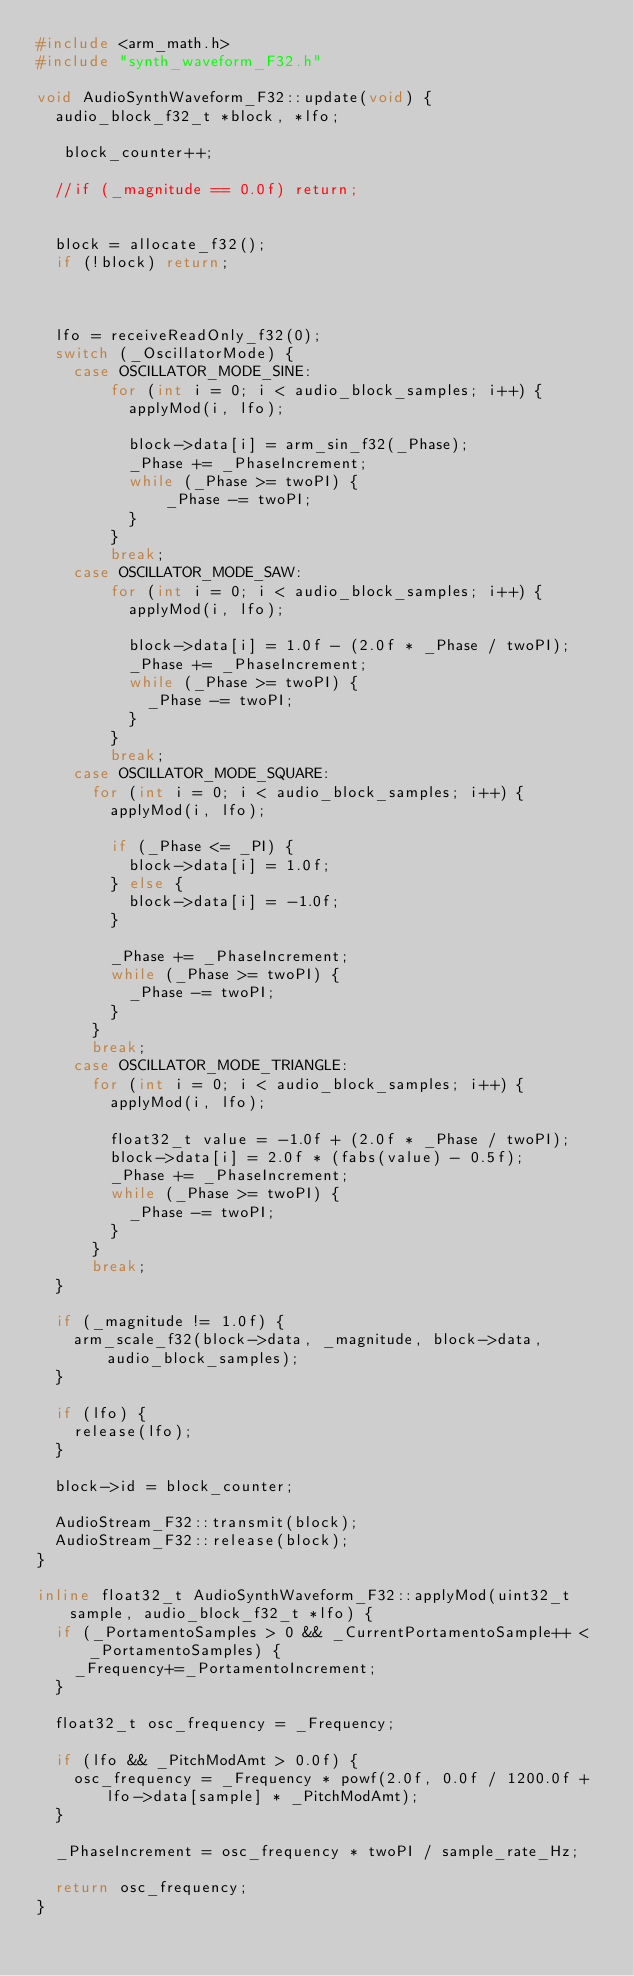<code> <loc_0><loc_0><loc_500><loc_500><_C++_>#include <arm_math.h>
#include "synth_waveform_F32.h"

void AudioSynthWaveform_F32::update(void) {
  audio_block_f32_t *block, *lfo;

   block_counter++;
	
  //if (_magnitude == 0.0f) return;
  

  block = allocate_f32();
  if (!block) return;
  
  

  lfo = receiveReadOnly_f32(0);
  switch (_OscillatorMode) {
    case OSCILLATOR_MODE_SINE:
        for (int i = 0; i < audio_block_samples; i++) {
          applyMod(i, lfo);

          block->data[i] = arm_sin_f32(_Phase);
          _Phase += _PhaseIncrement;
          while (_Phase >= twoPI) {
              _Phase -= twoPI;
          }
        }
        break;
    case OSCILLATOR_MODE_SAW:
        for (int i = 0; i < audio_block_samples; i++) {
          applyMod(i, lfo);

          block->data[i] = 1.0f - (2.0f * _Phase / twoPI);
          _Phase += _PhaseIncrement;
          while (_Phase >= twoPI) {
            _Phase -= twoPI;
          }
        }
        break;
    case OSCILLATOR_MODE_SQUARE:
      for (int i = 0; i < audio_block_samples; i++) {
        applyMod(i, lfo);

        if (_Phase <= _PI) {
          block->data[i] = 1.0f;
        } else {
          block->data[i] = -1.0f;
        }

        _Phase += _PhaseIncrement;
        while (_Phase >= twoPI) {
          _Phase -= twoPI;
        }
      }
      break;
    case OSCILLATOR_MODE_TRIANGLE:
      for (int i = 0; i < audio_block_samples; i++) {
        applyMod(i, lfo);

        float32_t value = -1.0f + (2.0f * _Phase / twoPI);
        block->data[i] = 2.0f * (fabs(value) - 0.5f);
        _Phase += _PhaseIncrement;
        while (_Phase >= twoPI) {
          _Phase -= twoPI;
        }
      }
      break;
  }

  if (_magnitude != 1.0f) {
    arm_scale_f32(block->data, _magnitude, block->data, audio_block_samples);
  }

  if (lfo) {
    release(lfo);
  }
  
  block->id = block_counter;

  AudioStream_F32::transmit(block);
  AudioStream_F32::release(block);
}

inline float32_t AudioSynthWaveform_F32::applyMod(uint32_t sample, audio_block_f32_t *lfo) {
  if (_PortamentoSamples > 0 && _CurrentPortamentoSample++ < _PortamentoSamples) {
    _Frequency+=_PortamentoIncrement;
  }

  float32_t osc_frequency = _Frequency;

  if (lfo && _PitchModAmt > 0.0f) {
    osc_frequency = _Frequency * powf(2.0f, 0.0f / 1200.0f + lfo->data[sample] * _PitchModAmt);
  }

  _PhaseIncrement = osc_frequency * twoPI / sample_rate_Hz;

  return osc_frequency;
}</code> 